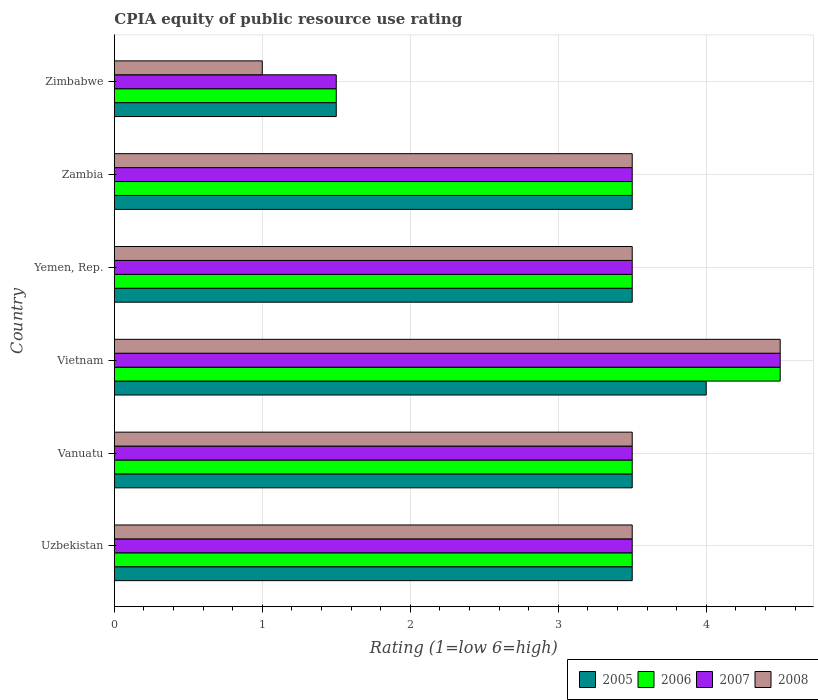How many bars are there on the 5th tick from the top?
Keep it short and to the point. 4. What is the label of the 3rd group of bars from the top?
Offer a terse response. Yemen, Rep. In how many cases, is the number of bars for a given country not equal to the number of legend labels?
Make the answer very short. 0. What is the CPIA rating in 2005 in Zimbabwe?
Your answer should be very brief. 1.5. Across all countries, what is the maximum CPIA rating in 2007?
Your answer should be very brief. 4.5. Across all countries, what is the minimum CPIA rating in 2005?
Make the answer very short. 1.5. In which country was the CPIA rating in 2008 maximum?
Keep it short and to the point. Vietnam. In which country was the CPIA rating in 2006 minimum?
Your answer should be compact. Zimbabwe. What is the difference between the CPIA rating in 2008 in Yemen, Rep. and the CPIA rating in 2006 in Vietnam?
Keep it short and to the point. -1. What is the average CPIA rating in 2007 per country?
Offer a terse response. 3.33. In how many countries, is the CPIA rating in 2008 greater than 1.8 ?
Your answer should be compact. 5. What is the ratio of the CPIA rating in 2005 in Uzbekistan to that in Vietnam?
Offer a very short reply. 0.88. What is the difference between the highest and the second highest CPIA rating in 2007?
Give a very brief answer. 1. What is the difference between the highest and the lowest CPIA rating in 2008?
Your answer should be compact. 3.5. Is the sum of the CPIA rating in 2005 in Vietnam and Zimbabwe greater than the maximum CPIA rating in 2006 across all countries?
Your answer should be compact. Yes. Is it the case that in every country, the sum of the CPIA rating in 2008 and CPIA rating in 2005 is greater than the sum of CPIA rating in 2007 and CPIA rating in 2006?
Keep it short and to the point. No. What does the 3rd bar from the top in Yemen, Rep. represents?
Keep it short and to the point. 2006. What does the 3rd bar from the bottom in Uzbekistan represents?
Keep it short and to the point. 2007. Are the values on the major ticks of X-axis written in scientific E-notation?
Provide a short and direct response. No. What is the title of the graph?
Keep it short and to the point. CPIA equity of public resource use rating. Does "1968" appear as one of the legend labels in the graph?
Make the answer very short. No. What is the label or title of the Y-axis?
Your response must be concise. Country. What is the Rating (1=low 6=high) of 2005 in Uzbekistan?
Offer a terse response. 3.5. What is the Rating (1=low 6=high) of 2006 in Uzbekistan?
Offer a terse response. 3.5. What is the Rating (1=low 6=high) of 2007 in Uzbekistan?
Ensure brevity in your answer.  3.5. What is the Rating (1=low 6=high) in 2008 in Uzbekistan?
Ensure brevity in your answer.  3.5. What is the Rating (1=low 6=high) of 2005 in Vanuatu?
Make the answer very short. 3.5. What is the Rating (1=low 6=high) in 2007 in Vanuatu?
Your answer should be very brief. 3.5. What is the Rating (1=low 6=high) in 2008 in Vanuatu?
Make the answer very short. 3.5. What is the Rating (1=low 6=high) in 2008 in Vietnam?
Your answer should be very brief. 4.5. What is the Rating (1=low 6=high) of 2005 in Yemen, Rep.?
Your response must be concise. 3.5. What is the Rating (1=low 6=high) of 2006 in Yemen, Rep.?
Offer a very short reply. 3.5. What is the Rating (1=low 6=high) in 2008 in Yemen, Rep.?
Provide a succinct answer. 3.5. What is the Rating (1=low 6=high) of 2006 in Zambia?
Your response must be concise. 3.5. What is the Rating (1=low 6=high) of 2007 in Zambia?
Your response must be concise. 3.5. What is the Rating (1=low 6=high) in 2008 in Zambia?
Keep it short and to the point. 3.5. What is the Rating (1=low 6=high) in 2006 in Zimbabwe?
Make the answer very short. 1.5. What is the Rating (1=low 6=high) in 2007 in Zimbabwe?
Your answer should be very brief. 1.5. What is the Rating (1=low 6=high) in 2008 in Zimbabwe?
Ensure brevity in your answer.  1. Across all countries, what is the maximum Rating (1=low 6=high) of 2005?
Provide a succinct answer. 4. Across all countries, what is the maximum Rating (1=low 6=high) in 2007?
Your answer should be very brief. 4.5. Across all countries, what is the minimum Rating (1=low 6=high) in 2005?
Ensure brevity in your answer.  1.5. Across all countries, what is the minimum Rating (1=low 6=high) of 2006?
Provide a short and direct response. 1.5. Across all countries, what is the minimum Rating (1=low 6=high) in 2007?
Provide a short and direct response. 1.5. What is the total Rating (1=low 6=high) in 2005 in the graph?
Make the answer very short. 19.5. What is the total Rating (1=low 6=high) of 2006 in the graph?
Your answer should be compact. 20. What is the total Rating (1=low 6=high) in 2007 in the graph?
Keep it short and to the point. 20. What is the total Rating (1=low 6=high) of 2008 in the graph?
Your answer should be compact. 19.5. What is the difference between the Rating (1=low 6=high) of 2005 in Uzbekistan and that in Vanuatu?
Your response must be concise. 0. What is the difference between the Rating (1=low 6=high) of 2006 in Uzbekistan and that in Vanuatu?
Your answer should be very brief. 0. What is the difference between the Rating (1=low 6=high) of 2008 in Uzbekistan and that in Vanuatu?
Your answer should be very brief. 0. What is the difference between the Rating (1=low 6=high) of 2006 in Uzbekistan and that in Vietnam?
Ensure brevity in your answer.  -1. What is the difference between the Rating (1=low 6=high) in 2005 in Uzbekistan and that in Yemen, Rep.?
Your answer should be very brief. 0. What is the difference between the Rating (1=low 6=high) in 2008 in Uzbekistan and that in Yemen, Rep.?
Give a very brief answer. 0. What is the difference between the Rating (1=low 6=high) of 2007 in Uzbekistan and that in Zambia?
Your answer should be very brief. 0. What is the difference between the Rating (1=low 6=high) of 2008 in Uzbekistan and that in Zambia?
Your response must be concise. 0. What is the difference between the Rating (1=low 6=high) in 2005 in Uzbekistan and that in Zimbabwe?
Provide a short and direct response. 2. What is the difference between the Rating (1=low 6=high) in 2008 in Vanuatu and that in Vietnam?
Make the answer very short. -1. What is the difference between the Rating (1=low 6=high) in 2006 in Vanuatu and that in Yemen, Rep.?
Your response must be concise. 0. What is the difference between the Rating (1=low 6=high) of 2005 in Vanuatu and that in Zambia?
Your answer should be compact. 0. What is the difference between the Rating (1=low 6=high) of 2008 in Vanuatu and that in Zambia?
Offer a terse response. 0. What is the difference between the Rating (1=low 6=high) in 2007 in Vanuatu and that in Zimbabwe?
Keep it short and to the point. 2. What is the difference between the Rating (1=low 6=high) of 2006 in Vietnam and that in Yemen, Rep.?
Provide a short and direct response. 1. What is the difference between the Rating (1=low 6=high) of 2008 in Vietnam and that in Yemen, Rep.?
Provide a short and direct response. 1. What is the difference between the Rating (1=low 6=high) in 2005 in Vietnam and that in Zambia?
Your answer should be very brief. 0.5. What is the difference between the Rating (1=low 6=high) in 2008 in Vietnam and that in Zambia?
Give a very brief answer. 1. What is the difference between the Rating (1=low 6=high) in 2006 in Vietnam and that in Zimbabwe?
Offer a very short reply. 3. What is the difference between the Rating (1=low 6=high) of 2007 in Vietnam and that in Zimbabwe?
Provide a short and direct response. 3. What is the difference between the Rating (1=low 6=high) in 2006 in Yemen, Rep. and that in Zambia?
Give a very brief answer. 0. What is the difference between the Rating (1=low 6=high) in 2007 in Yemen, Rep. and that in Zambia?
Ensure brevity in your answer.  0. What is the difference between the Rating (1=low 6=high) of 2008 in Yemen, Rep. and that in Zambia?
Offer a terse response. 0. What is the difference between the Rating (1=low 6=high) of 2006 in Yemen, Rep. and that in Zimbabwe?
Give a very brief answer. 2. What is the difference between the Rating (1=low 6=high) in 2006 in Zambia and that in Zimbabwe?
Make the answer very short. 2. What is the difference between the Rating (1=low 6=high) of 2007 in Zambia and that in Zimbabwe?
Give a very brief answer. 2. What is the difference between the Rating (1=low 6=high) in 2008 in Zambia and that in Zimbabwe?
Make the answer very short. 2.5. What is the difference between the Rating (1=low 6=high) in 2005 in Uzbekistan and the Rating (1=low 6=high) in 2006 in Vanuatu?
Give a very brief answer. 0. What is the difference between the Rating (1=low 6=high) in 2005 in Uzbekistan and the Rating (1=low 6=high) in 2007 in Vanuatu?
Ensure brevity in your answer.  0. What is the difference between the Rating (1=low 6=high) in 2005 in Uzbekistan and the Rating (1=low 6=high) in 2008 in Vanuatu?
Your answer should be very brief. 0. What is the difference between the Rating (1=low 6=high) of 2006 in Uzbekistan and the Rating (1=low 6=high) of 2008 in Vanuatu?
Offer a terse response. 0. What is the difference between the Rating (1=low 6=high) of 2005 in Uzbekistan and the Rating (1=low 6=high) of 2006 in Vietnam?
Offer a very short reply. -1. What is the difference between the Rating (1=low 6=high) of 2005 in Uzbekistan and the Rating (1=low 6=high) of 2007 in Vietnam?
Provide a succinct answer. -1. What is the difference between the Rating (1=low 6=high) in 2005 in Uzbekistan and the Rating (1=low 6=high) in 2008 in Vietnam?
Give a very brief answer. -1. What is the difference between the Rating (1=low 6=high) in 2006 in Uzbekistan and the Rating (1=low 6=high) in 2007 in Vietnam?
Your answer should be compact. -1. What is the difference between the Rating (1=low 6=high) of 2005 in Uzbekistan and the Rating (1=low 6=high) of 2006 in Yemen, Rep.?
Ensure brevity in your answer.  0. What is the difference between the Rating (1=low 6=high) of 2005 in Uzbekistan and the Rating (1=low 6=high) of 2007 in Yemen, Rep.?
Give a very brief answer. 0. What is the difference between the Rating (1=low 6=high) in 2005 in Uzbekistan and the Rating (1=low 6=high) in 2008 in Yemen, Rep.?
Keep it short and to the point. 0. What is the difference between the Rating (1=low 6=high) of 2006 in Uzbekistan and the Rating (1=low 6=high) of 2007 in Yemen, Rep.?
Provide a short and direct response. 0. What is the difference between the Rating (1=low 6=high) of 2006 in Uzbekistan and the Rating (1=low 6=high) of 2008 in Yemen, Rep.?
Your answer should be compact. 0. What is the difference between the Rating (1=low 6=high) in 2007 in Uzbekistan and the Rating (1=low 6=high) in 2008 in Yemen, Rep.?
Your response must be concise. 0. What is the difference between the Rating (1=low 6=high) of 2005 in Uzbekistan and the Rating (1=low 6=high) of 2006 in Zambia?
Provide a short and direct response. 0. What is the difference between the Rating (1=low 6=high) in 2005 in Uzbekistan and the Rating (1=low 6=high) in 2008 in Zambia?
Keep it short and to the point. 0. What is the difference between the Rating (1=low 6=high) of 2007 in Uzbekistan and the Rating (1=low 6=high) of 2008 in Zambia?
Your answer should be compact. 0. What is the difference between the Rating (1=low 6=high) in 2007 in Uzbekistan and the Rating (1=low 6=high) in 2008 in Zimbabwe?
Your answer should be very brief. 2.5. What is the difference between the Rating (1=low 6=high) of 2005 in Vanuatu and the Rating (1=low 6=high) of 2006 in Yemen, Rep.?
Provide a short and direct response. 0. What is the difference between the Rating (1=low 6=high) in 2005 in Vanuatu and the Rating (1=low 6=high) in 2007 in Yemen, Rep.?
Give a very brief answer. 0. What is the difference between the Rating (1=low 6=high) in 2005 in Vanuatu and the Rating (1=low 6=high) in 2006 in Zambia?
Provide a short and direct response. 0. What is the difference between the Rating (1=low 6=high) in 2006 in Vanuatu and the Rating (1=low 6=high) in 2007 in Zambia?
Your answer should be compact. 0. What is the difference between the Rating (1=low 6=high) of 2006 in Vanuatu and the Rating (1=low 6=high) of 2008 in Zambia?
Provide a succinct answer. 0. What is the difference between the Rating (1=low 6=high) in 2005 in Vanuatu and the Rating (1=low 6=high) in 2006 in Zimbabwe?
Make the answer very short. 2. What is the difference between the Rating (1=low 6=high) in 2005 in Vanuatu and the Rating (1=low 6=high) in 2007 in Zimbabwe?
Provide a succinct answer. 2. What is the difference between the Rating (1=low 6=high) in 2005 in Vanuatu and the Rating (1=low 6=high) in 2008 in Zimbabwe?
Provide a short and direct response. 2.5. What is the difference between the Rating (1=low 6=high) of 2006 in Vanuatu and the Rating (1=low 6=high) of 2008 in Zimbabwe?
Make the answer very short. 2.5. What is the difference between the Rating (1=low 6=high) of 2007 in Vanuatu and the Rating (1=low 6=high) of 2008 in Zimbabwe?
Offer a terse response. 2.5. What is the difference between the Rating (1=low 6=high) in 2005 in Vietnam and the Rating (1=low 6=high) in 2006 in Yemen, Rep.?
Provide a short and direct response. 0.5. What is the difference between the Rating (1=low 6=high) of 2006 in Vietnam and the Rating (1=low 6=high) of 2007 in Yemen, Rep.?
Keep it short and to the point. 1. What is the difference between the Rating (1=low 6=high) of 2005 in Vietnam and the Rating (1=low 6=high) of 2007 in Zambia?
Keep it short and to the point. 0.5. What is the difference between the Rating (1=low 6=high) of 2005 in Vietnam and the Rating (1=low 6=high) of 2008 in Zambia?
Provide a succinct answer. 0.5. What is the difference between the Rating (1=low 6=high) in 2006 in Vietnam and the Rating (1=low 6=high) in 2007 in Zambia?
Provide a short and direct response. 1. What is the difference between the Rating (1=low 6=high) of 2007 in Vietnam and the Rating (1=low 6=high) of 2008 in Zambia?
Ensure brevity in your answer.  1. What is the difference between the Rating (1=low 6=high) of 2005 in Vietnam and the Rating (1=low 6=high) of 2006 in Zimbabwe?
Give a very brief answer. 2.5. What is the difference between the Rating (1=low 6=high) of 2005 in Vietnam and the Rating (1=low 6=high) of 2007 in Zimbabwe?
Provide a succinct answer. 2.5. What is the difference between the Rating (1=low 6=high) of 2005 in Vietnam and the Rating (1=low 6=high) of 2008 in Zimbabwe?
Keep it short and to the point. 3. What is the difference between the Rating (1=low 6=high) of 2007 in Vietnam and the Rating (1=low 6=high) of 2008 in Zimbabwe?
Offer a very short reply. 3.5. What is the difference between the Rating (1=low 6=high) of 2005 in Yemen, Rep. and the Rating (1=low 6=high) of 2008 in Zambia?
Your answer should be compact. 0. What is the difference between the Rating (1=low 6=high) in 2006 in Yemen, Rep. and the Rating (1=low 6=high) in 2008 in Zambia?
Ensure brevity in your answer.  0. What is the difference between the Rating (1=low 6=high) in 2007 in Yemen, Rep. and the Rating (1=low 6=high) in 2008 in Zimbabwe?
Offer a terse response. 2.5. What is the difference between the Rating (1=low 6=high) of 2005 in Zambia and the Rating (1=low 6=high) of 2006 in Zimbabwe?
Offer a terse response. 2. What is the difference between the Rating (1=low 6=high) of 2005 in Zambia and the Rating (1=low 6=high) of 2007 in Zimbabwe?
Provide a short and direct response. 2. What is the difference between the Rating (1=low 6=high) of 2005 in Zambia and the Rating (1=low 6=high) of 2008 in Zimbabwe?
Your response must be concise. 2.5. What is the difference between the Rating (1=low 6=high) of 2006 in Zambia and the Rating (1=low 6=high) of 2007 in Zimbabwe?
Keep it short and to the point. 2. What is the difference between the Rating (1=low 6=high) of 2006 in Zambia and the Rating (1=low 6=high) of 2008 in Zimbabwe?
Keep it short and to the point. 2.5. What is the difference between the Rating (1=low 6=high) in 2007 in Zambia and the Rating (1=low 6=high) in 2008 in Zimbabwe?
Provide a short and direct response. 2.5. What is the average Rating (1=low 6=high) of 2005 per country?
Your response must be concise. 3.25. What is the average Rating (1=low 6=high) of 2007 per country?
Your answer should be very brief. 3.33. What is the difference between the Rating (1=low 6=high) in 2005 and Rating (1=low 6=high) in 2006 in Uzbekistan?
Your answer should be very brief. 0. What is the difference between the Rating (1=low 6=high) of 2005 and Rating (1=low 6=high) of 2008 in Uzbekistan?
Your response must be concise. 0. What is the difference between the Rating (1=low 6=high) of 2006 and Rating (1=low 6=high) of 2007 in Uzbekistan?
Ensure brevity in your answer.  0. What is the difference between the Rating (1=low 6=high) in 2005 and Rating (1=low 6=high) in 2007 in Vanuatu?
Offer a terse response. 0. What is the difference between the Rating (1=low 6=high) in 2006 and Rating (1=low 6=high) in 2007 in Vanuatu?
Ensure brevity in your answer.  0. What is the difference between the Rating (1=low 6=high) of 2006 and Rating (1=low 6=high) of 2008 in Vanuatu?
Make the answer very short. 0. What is the difference between the Rating (1=low 6=high) in 2007 and Rating (1=low 6=high) in 2008 in Vanuatu?
Give a very brief answer. 0. What is the difference between the Rating (1=low 6=high) of 2005 and Rating (1=low 6=high) of 2006 in Vietnam?
Offer a very short reply. -0.5. What is the difference between the Rating (1=low 6=high) in 2005 and Rating (1=low 6=high) in 2006 in Yemen, Rep.?
Provide a succinct answer. 0. What is the difference between the Rating (1=low 6=high) of 2005 and Rating (1=low 6=high) of 2007 in Yemen, Rep.?
Give a very brief answer. 0. What is the difference between the Rating (1=low 6=high) in 2005 and Rating (1=low 6=high) in 2008 in Yemen, Rep.?
Give a very brief answer. 0. What is the difference between the Rating (1=low 6=high) of 2007 and Rating (1=low 6=high) of 2008 in Yemen, Rep.?
Your response must be concise. 0. What is the difference between the Rating (1=low 6=high) of 2005 and Rating (1=low 6=high) of 2006 in Zambia?
Offer a very short reply. 0. What is the difference between the Rating (1=low 6=high) in 2005 and Rating (1=low 6=high) in 2007 in Zambia?
Give a very brief answer. 0. What is the difference between the Rating (1=low 6=high) in 2005 and Rating (1=low 6=high) in 2006 in Zimbabwe?
Give a very brief answer. 0. What is the difference between the Rating (1=low 6=high) in 2006 and Rating (1=low 6=high) in 2007 in Zimbabwe?
Ensure brevity in your answer.  0. What is the difference between the Rating (1=low 6=high) in 2006 and Rating (1=low 6=high) in 2008 in Zimbabwe?
Your answer should be compact. 0.5. What is the difference between the Rating (1=low 6=high) of 2007 and Rating (1=low 6=high) of 2008 in Zimbabwe?
Make the answer very short. 0.5. What is the ratio of the Rating (1=low 6=high) in 2006 in Uzbekistan to that in Vanuatu?
Ensure brevity in your answer.  1. What is the ratio of the Rating (1=low 6=high) in 2007 in Uzbekistan to that in Vanuatu?
Offer a terse response. 1. What is the ratio of the Rating (1=low 6=high) in 2008 in Uzbekistan to that in Vanuatu?
Ensure brevity in your answer.  1. What is the ratio of the Rating (1=low 6=high) in 2005 in Uzbekistan to that in Vietnam?
Provide a short and direct response. 0.88. What is the ratio of the Rating (1=low 6=high) of 2006 in Uzbekistan to that in Vietnam?
Your answer should be compact. 0.78. What is the ratio of the Rating (1=low 6=high) of 2005 in Uzbekistan to that in Yemen, Rep.?
Your response must be concise. 1. What is the ratio of the Rating (1=low 6=high) in 2005 in Uzbekistan to that in Zambia?
Give a very brief answer. 1. What is the ratio of the Rating (1=low 6=high) of 2007 in Uzbekistan to that in Zambia?
Offer a very short reply. 1. What is the ratio of the Rating (1=low 6=high) of 2008 in Uzbekistan to that in Zambia?
Your answer should be compact. 1. What is the ratio of the Rating (1=low 6=high) of 2005 in Uzbekistan to that in Zimbabwe?
Provide a short and direct response. 2.33. What is the ratio of the Rating (1=low 6=high) of 2006 in Uzbekistan to that in Zimbabwe?
Your answer should be compact. 2.33. What is the ratio of the Rating (1=low 6=high) of 2007 in Uzbekistan to that in Zimbabwe?
Make the answer very short. 2.33. What is the ratio of the Rating (1=low 6=high) of 2008 in Uzbekistan to that in Zimbabwe?
Your answer should be very brief. 3.5. What is the ratio of the Rating (1=low 6=high) of 2006 in Vanuatu to that in Vietnam?
Make the answer very short. 0.78. What is the ratio of the Rating (1=low 6=high) of 2007 in Vanuatu to that in Vietnam?
Give a very brief answer. 0.78. What is the ratio of the Rating (1=low 6=high) in 2008 in Vanuatu to that in Vietnam?
Offer a very short reply. 0.78. What is the ratio of the Rating (1=low 6=high) in 2008 in Vanuatu to that in Yemen, Rep.?
Make the answer very short. 1. What is the ratio of the Rating (1=low 6=high) in 2005 in Vanuatu to that in Zambia?
Make the answer very short. 1. What is the ratio of the Rating (1=low 6=high) of 2006 in Vanuatu to that in Zambia?
Your answer should be compact. 1. What is the ratio of the Rating (1=low 6=high) in 2008 in Vanuatu to that in Zambia?
Give a very brief answer. 1. What is the ratio of the Rating (1=low 6=high) of 2005 in Vanuatu to that in Zimbabwe?
Offer a terse response. 2.33. What is the ratio of the Rating (1=low 6=high) of 2006 in Vanuatu to that in Zimbabwe?
Your answer should be very brief. 2.33. What is the ratio of the Rating (1=low 6=high) in 2007 in Vanuatu to that in Zimbabwe?
Ensure brevity in your answer.  2.33. What is the ratio of the Rating (1=low 6=high) of 2006 in Vietnam to that in Yemen, Rep.?
Ensure brevity in your answer.  1.29. What is the ratio of the Rating (1=low 6=high) in 2007 in Vietnam to that in Yemen, Rep.?
Your answer should be very brief. 1.29. What is the ratio of the Rating (1=low 6=high) of 2005 in Vietnam to that in Zambia?
Provide a short and direct response. 1.14. What is the ratio of the Rating (1=low 6=high) in 2006 in Vietnam to that in Zambia?
Your answer should be very brief. 1.29. What is the ratio of the Rating (1=low 6=high) of 2008 in Vietnam to that in Zambia?
Make the answer very short. 1.29. What is the ratio of the Rating (1=low 6=high) in 2005 in Vietnam to that in Zimbabwe?
Give a very brief answer. 2.67. What is the ratio of the Rating (1=low 6=high) in 2006 in Vietnam to that in Zimbabwe?
Keep it short and to the point. 3. What is the ratio of the Rating (1=low 6=high) of 2005 in Yemen, Rep. to that in Zambia?
Offer a very short reply. 1. What is the ratio of the Rating (1=low 6=high) of 2005 in Yemen, Rep. to that in Zimbabwe?
Ensure brevity in your answer.  2.33. What is the ratio of the Rating (1=low 6=high) of 2006 in Yemen, Rep. to that in Zimbabwe?
Keep it short and to the point. 2.33. What is the ratio of the Rating (1=low 6=high) in 2007 in Yemen, Rep. to that in Zimbabwe?
Ensure brevity in your answer.  2.33. What is the ratio of the Rating (1=low 6=high) of 2005 in Zambia to that in Zimbabwe?
Ensure brevity in your answer.  2.33. What is the ratio of the Rating (1=low 6=high) of 2006 in Zambia to that in Zimbabwe?
Your answer should be compact. 2.33. What is the ratio of the Rating (1=low 6=high) in 2007 in Zambia to that in Zimbabwe?
Make the answer very short. 2.33. What is the difference between the highest and the second highest Rating (1=low 6=high) in 2006?
Your answer should be very brief. 1. What is the difference between the highest and the second highest Rating (1=low 6=high) of 2007?
Your answer should be very brief. 1. 